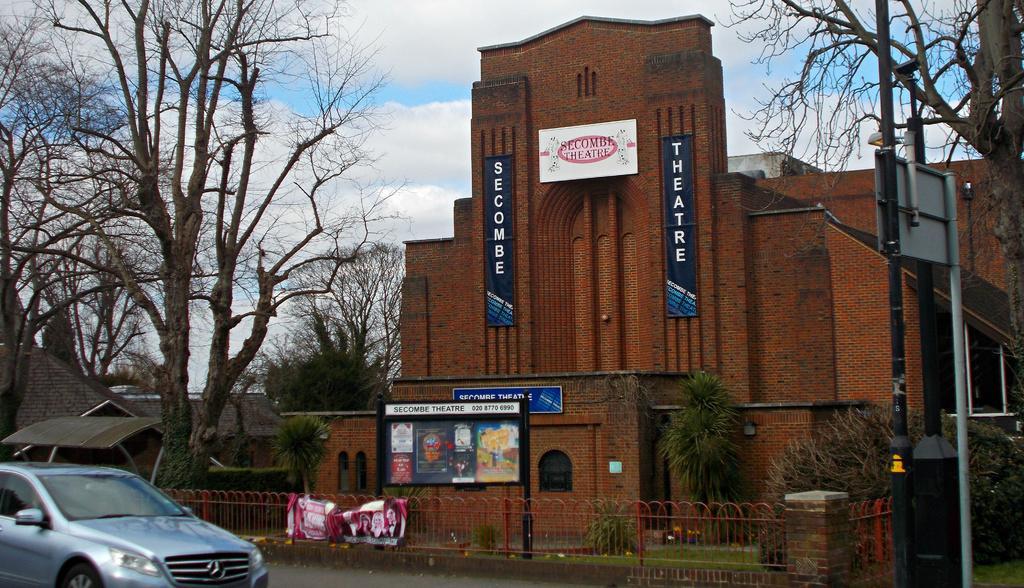Describe this image in one or two sentences. In this picture we can see a building here, there is a hoarding and a board here, at the bottom there is a fencing panel, on the left side we can see trees and a car, on the right side there is a pole and a board, we can see the sky at the top of the picture, there is grass here. 